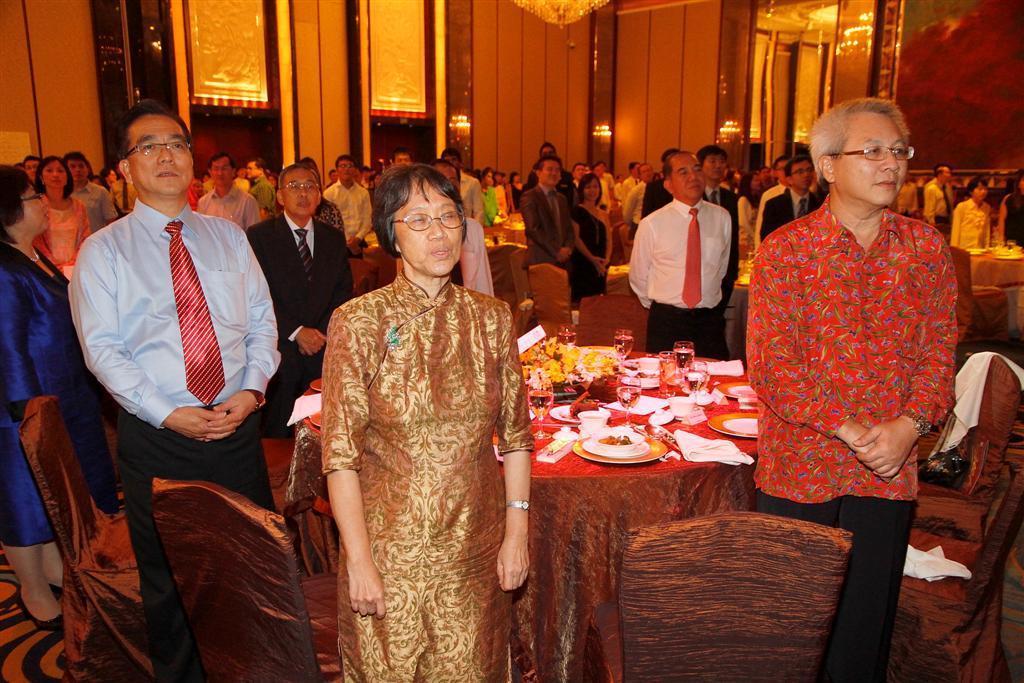Can you describe this image briefly? In this image I can see a number of persons stand ,in front I can see a table ,on the table I can see a colorful cloth and on the table there are plates ,glass,flowers kept on the table ,around the table I can see a chairs and background I can see a wall. 